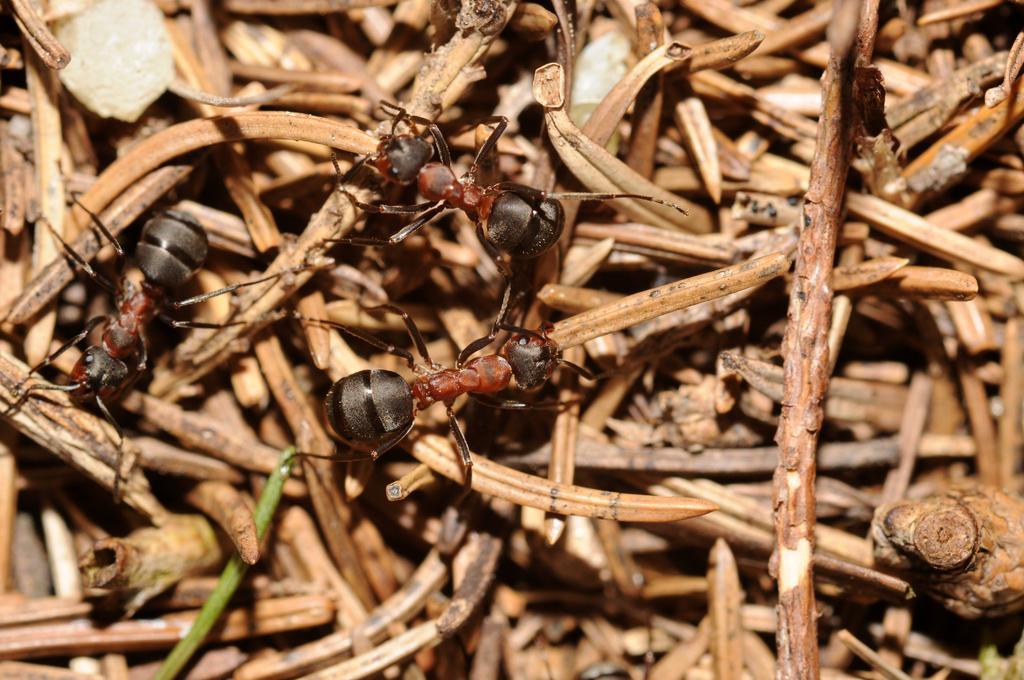Describe this image in one or two sentences. This picture contains three ants. In the background, we see small wooden sticks or twigs. 